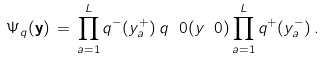<formula> <loc_0><loc_0><loc_500><loc_500>\Psi _ { q } ( { \mathbf y } ) \, = \, \prod _ { a = 1 } ^ { L } q ^ { - } ( y _ { a } ^ { + } ) \, q ^ { \ } 0 ( y _ { \ } 0 ) \prod _ { a = 1 } ^ { L } q ^ { + } ( y _ { a } ^ { - } ) \, .</formula> 